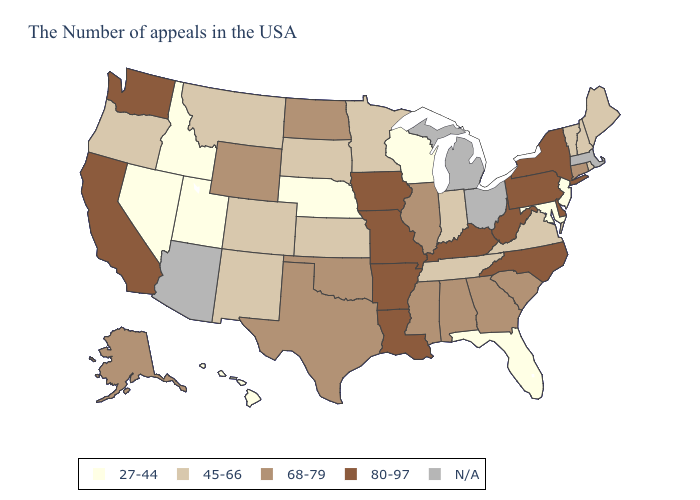Does New Mexico have the highest value in the USA?
Be succinct. No. Name the states that have a value in the range 45-66?
Be succinct. Maine, Rhode Island, New Hampshire, Vermont, Virginia, Indiana, Tennessee, Minnesota, Kansas, South Dakota, Colorado, New Mexico, Montana, Oregon. What is the value of Louisiana?
Quick response, please. 80-97. Does Kansas have the highest value in the USA?
Answer briefly. No. What is the value of Delaware?
Short answer required. 80-97. Name the states that have a value in the range 80-97?
Short answer required. New York, Delaware, Pennsylvania, North Carolina, West Virginia, Kentucky, Louisiana, Missouri, Arkansas, Iowa, California, Washington. Among the states that border Arkansas , does Missouri have the highest value?
Short answer required. Yes. What is the highest value in the USA?
Short answer required. 80-97. What is the value of Nevada?
Concise answer only. 27-44. What is the value of North Carolina?
Write a very short answer. 80-97. How many symbols are there in the legend?
Concise answer only. 5. Does Louisiana have the highest value in the USA?
Quick response, please. Yes. Among the states that border South Carolina , which have the lowest value?
Answer briefly. Georgia. Does Iowa have the highest value in the USA?
Concise answer only. Yes. 